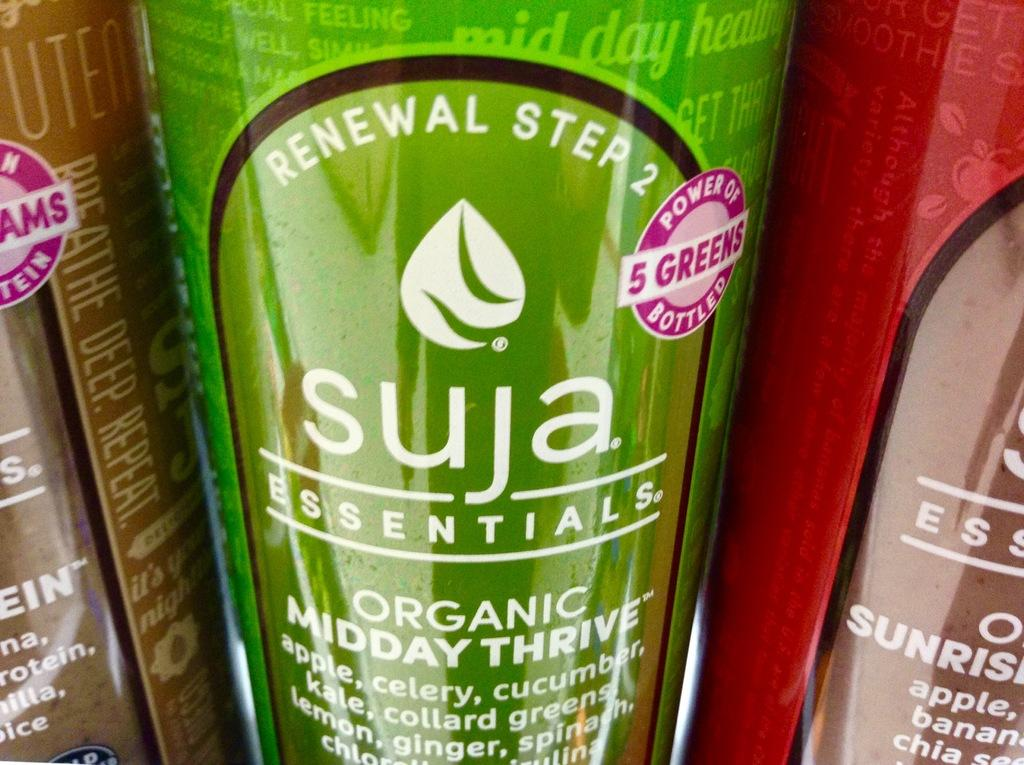<image>
Give a short and clear explanation of the subsequent image. a bottle that has suja written on it 